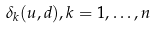<formula> <loc_0><loc_0><loc_500><loc_500>\delta _ { k } ( u , d ) , k = 1 , \dots , n</formula> 